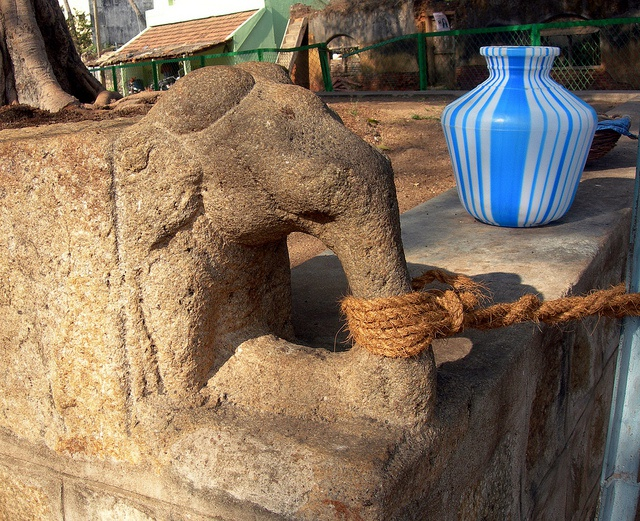Describe the objects in this image and their specific colors. I can see vase in brown, gray, blue, and darkgray tones and motorcycle in brown, black, gray, and maroon tones in this image. 